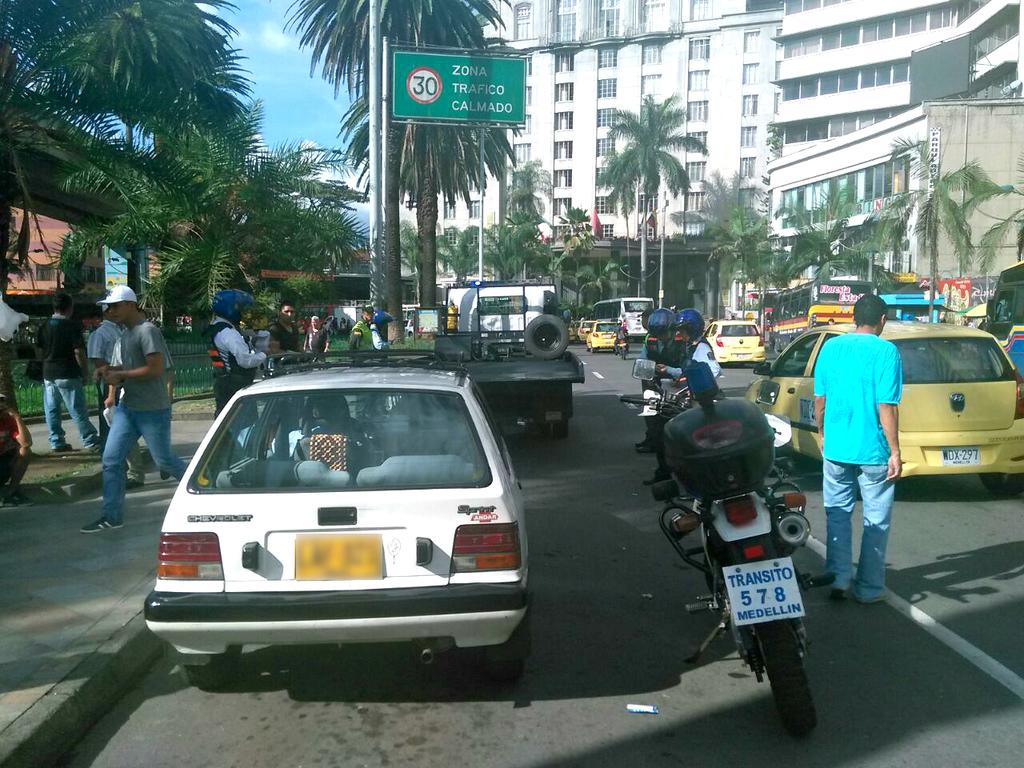<image>
Describe the image concisely. a bike that has the number 578 on the back 